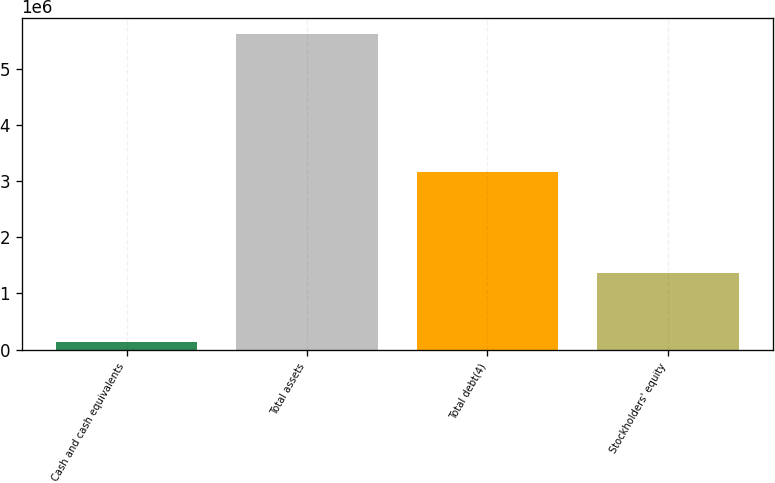<chart> <loc_0><loc_0><loc_500><loc_500><bar_chart><fcel>Cash and cash equivalents<fcel>Total assets<fcel>Total debt(4)<fcel>Stockholders' equity<nl><fcel>138348<fcel>5.61593e+06<fcel>3.16799e+06<fcel>1.37201e+06<nl></chart> 